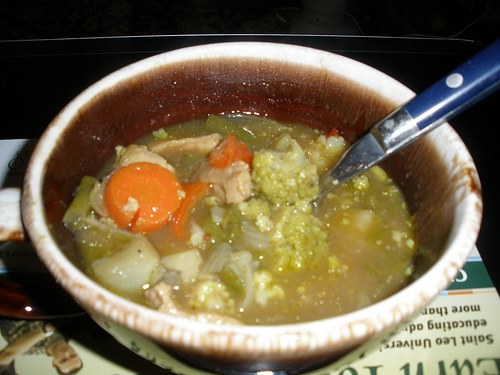What emotions does this image evoke? This image evokes feelings of warmth, comfort, and satisfaction. The hearty bowl of soup suggests a wholesome, nourishing meal, possibly homemade, bringing to mind cozy family dinners and the love and care put into preparing food for loved ones. 